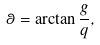Convert formula to latex. <formula><loc_0><loc_0><loc_500><loc_500>\theta = \arctan \frac { g } { q } ,</formula> 